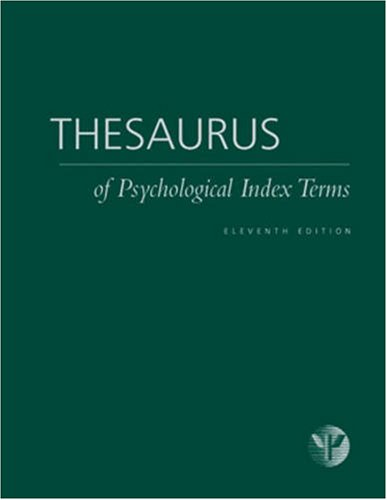Is this book related to Mystery, Thriller & Suspense? No, this book is not related to the genres of Mystery, Thriller, or Suspense. It's purely an academic reference book dealing with psychological terms. 